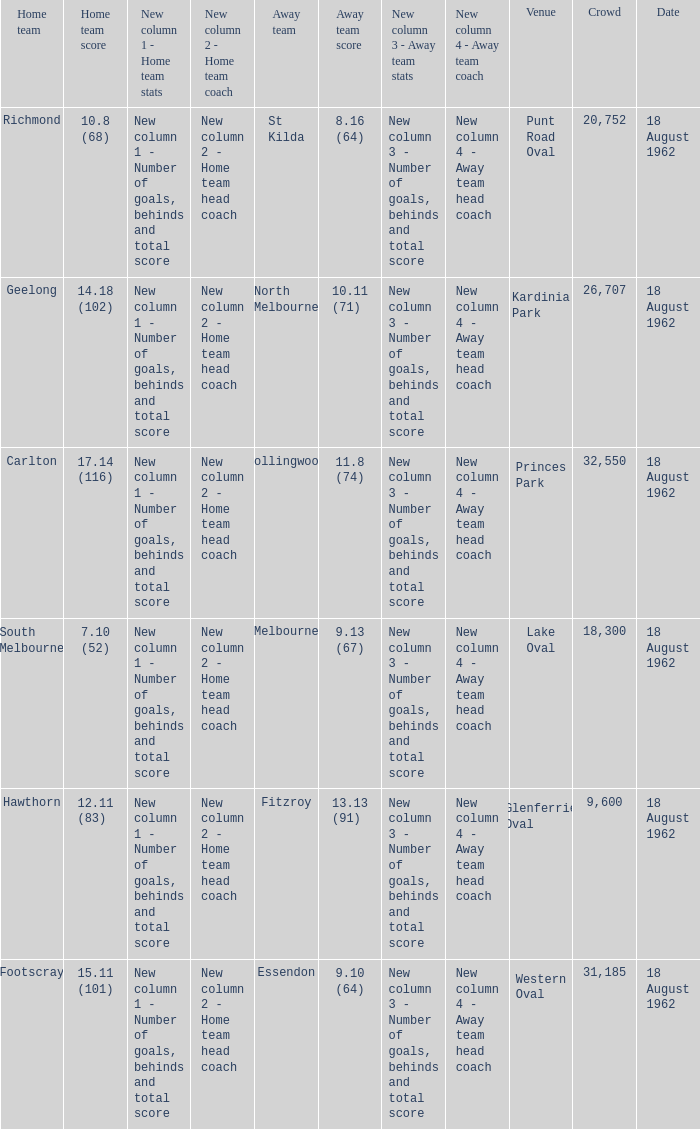When the home team scored 10.8 (68), who were their opponents playing as the away team? St Kilda. 